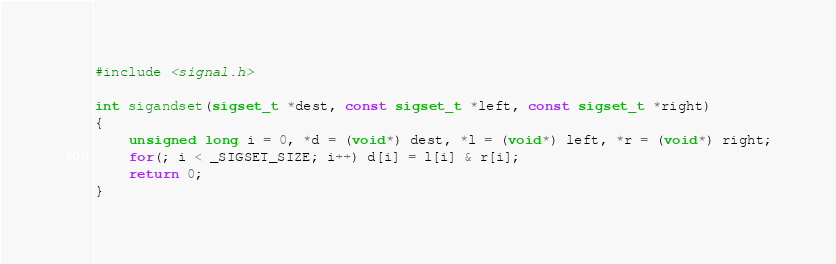Convert code to text. <code><loc_0><loc_0><loc_500><loc_500><_C_>#include <signal.h>

int sigandset(sigset_t *dest, const sigset_t *left, const sigset_t *right)
{
	unsigned long i = 0, *d = (void*) dest, *l = (void*) left, *r = (void*) right;
	for(; i < _SIGSET_SIZE; i++) d[i] = l[i] & r[i];
	return 0;
}

</code> 